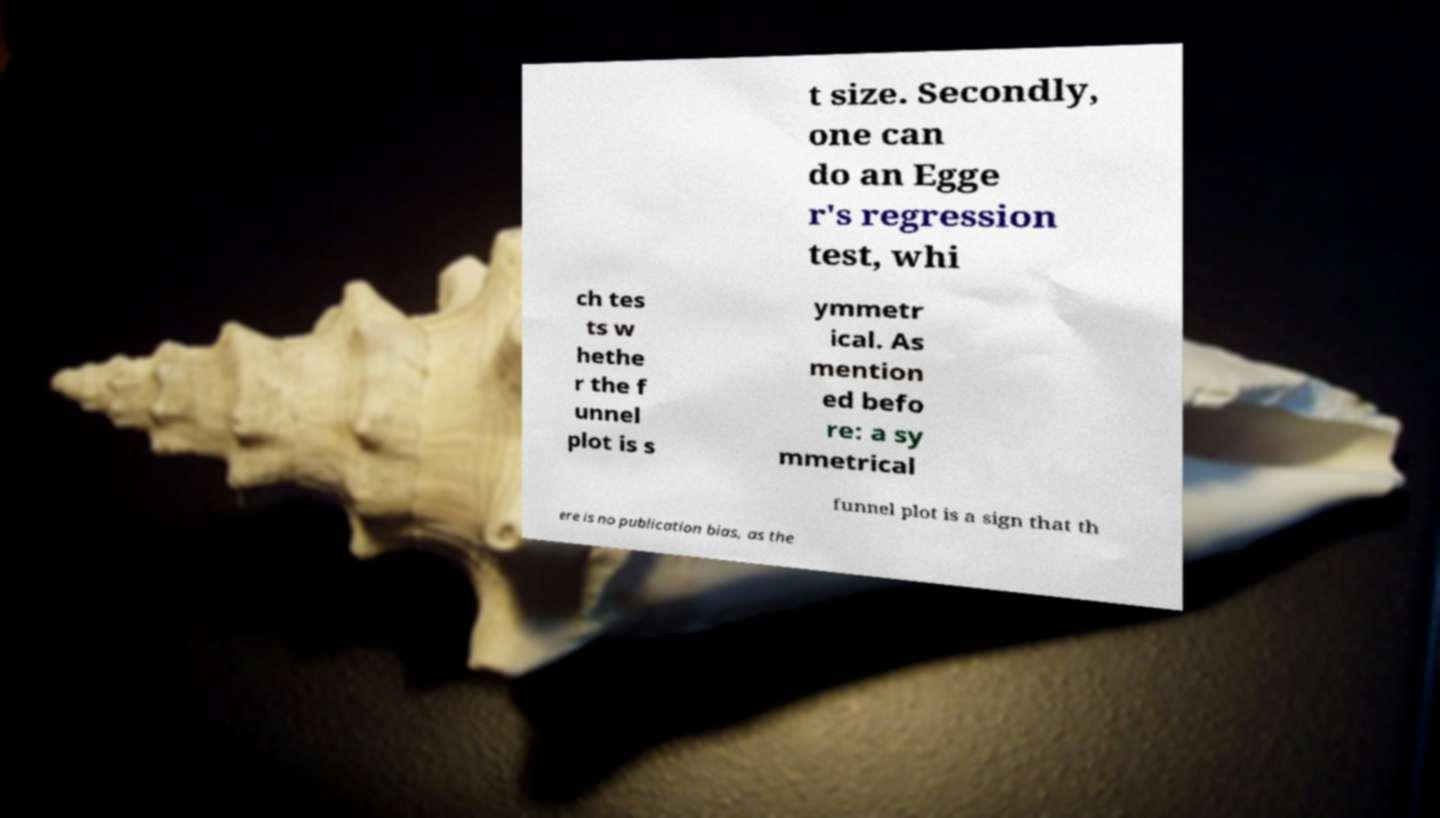Can you accurately transcribe the text from the provided image for me? t size. Secondly, one can do an Egge r's regression test, whi ch tes ts w hethe r the f unnel plot is s ymmetr ical. As mention ed befo re: a sy mmetrical funnel plot is a sign that th ere is no publication bias, as the 